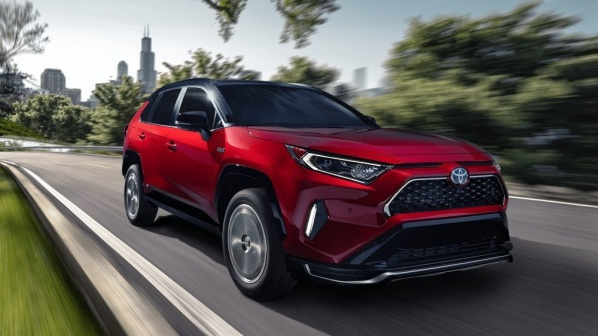If you were to create a commercial for this car, what would the main theme be? The main theme of the commercial would be 'Urban Agility.' The ad would showcase the red Toyota RAV4 navigating through a bustling city landscape, emphasizing its sleek design, advanced safety features, and seamless integration into an urban lifestyle. Clips of the car smoothly transitioning from city streets to scenic drives highlight its versatility and performance in various environments. 